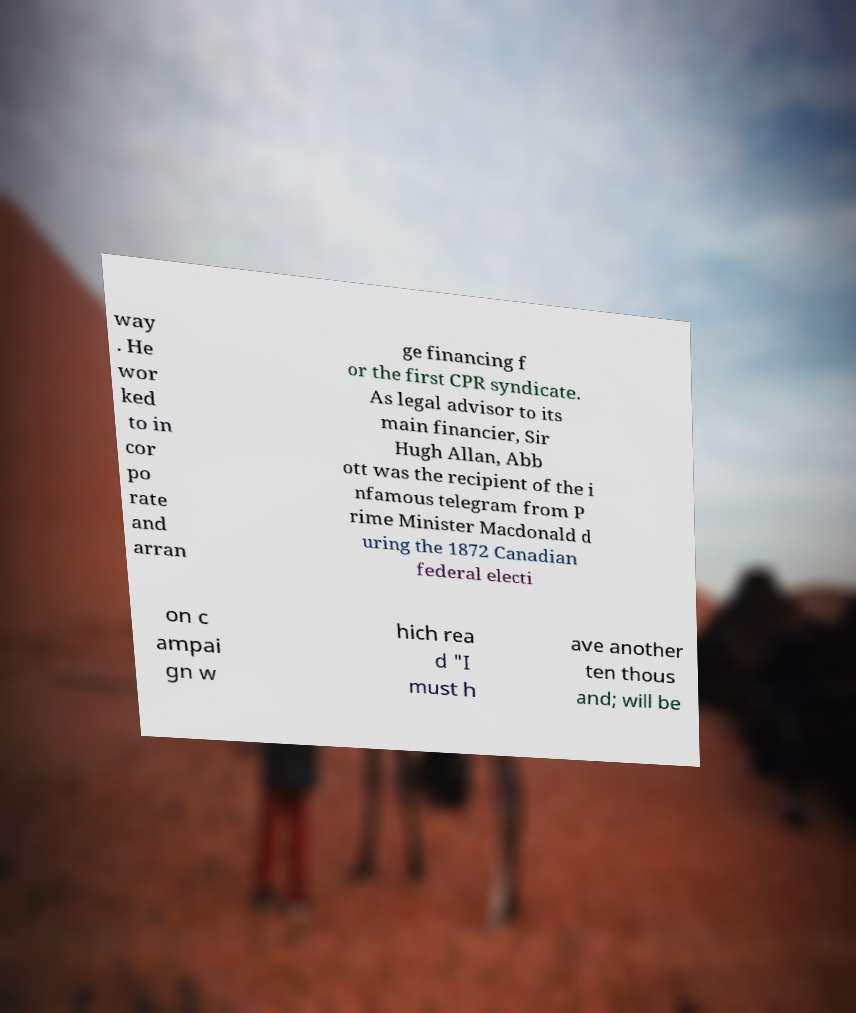There's text embedded in this image that I need extracted. Can you transcribe it verbatim? way . He wor ked to in cor po rate and arran ge financing f or the first CPR syndicate. As legal advisor to its main financier, Sir Hugh Allan, Abb ott was the recipient of the i nfamous telegram from P rime Minister Macdonald d uring the 1872 Canadian federal electi on c ampai gn w hich rea d "I must h ave another ten thous and; will be 